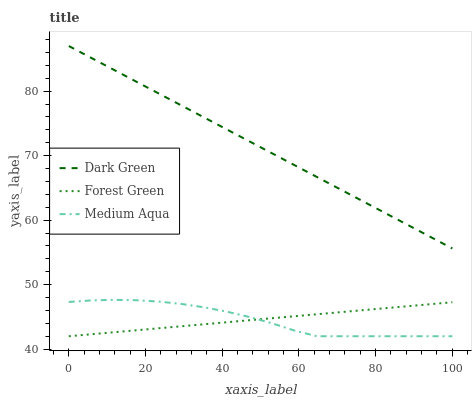Does Medium Aqua have the minimum area under the curve?
Answer yes or no. Yes. Does Dark Green have the maximum area under the curve?
Answer yes or no. Yes. Does Dark Green have the minimum area under the curve?
Answer yes or no. No. Does Medium Aqua have the maximum area under the curve?
Answer yes or no. No. Is Forest Green the smoothest?
Answer yes or no. Yes. Is Medium Aqua the roughest?
Answer yes or no. Yes. Is Dark Green the smoothest?
Answer yes or no. No. Is Dark Green the roughest?
Answer yes or no. No. Does Forest Green have the lowest value?
Answer yes or no. Yes. Does Dark Green have the lowest value?
Answer yes or no. No. Does Dark Green have the highest value?
Answer yes or no. Yes. Does Medium Aqua have the highest value?
Answer yes or no. No. Is Forest Green less than Dark Green?
Answer yes or no. Yes. Is Dark Green greater than Forest Green?
Answer yes or no. Yes. Does Forest Green intersect Medium Aqua?
Answer yes or no. Yes. Is Forest Green less than Medium Aqua?
Answer yes or no. No. Is Forest Green greater than Medium Aqua?
Answer yes or no. No. Does Forest Green intersect Dark Green?
Answer yes or no. No. 